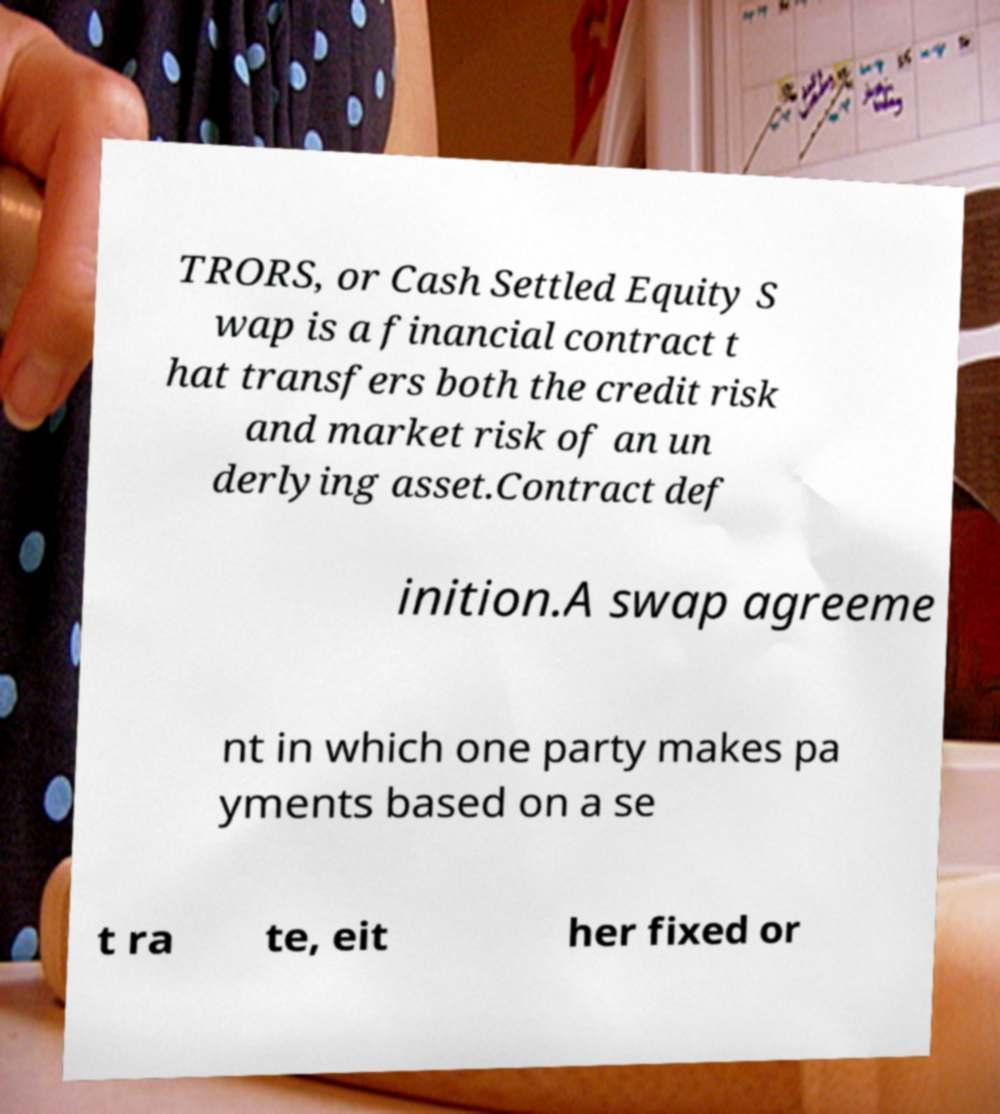Please identify and transcribe the text found in this image. TRORS, or Cash Settled Equity S wap is a financial contract t hat transfers both the credit risk and market risk of an un derlying asset.Contract def inition.A swap agreeme nt in which one party makes pa yments based on a se t ra te, eit her fixed or 